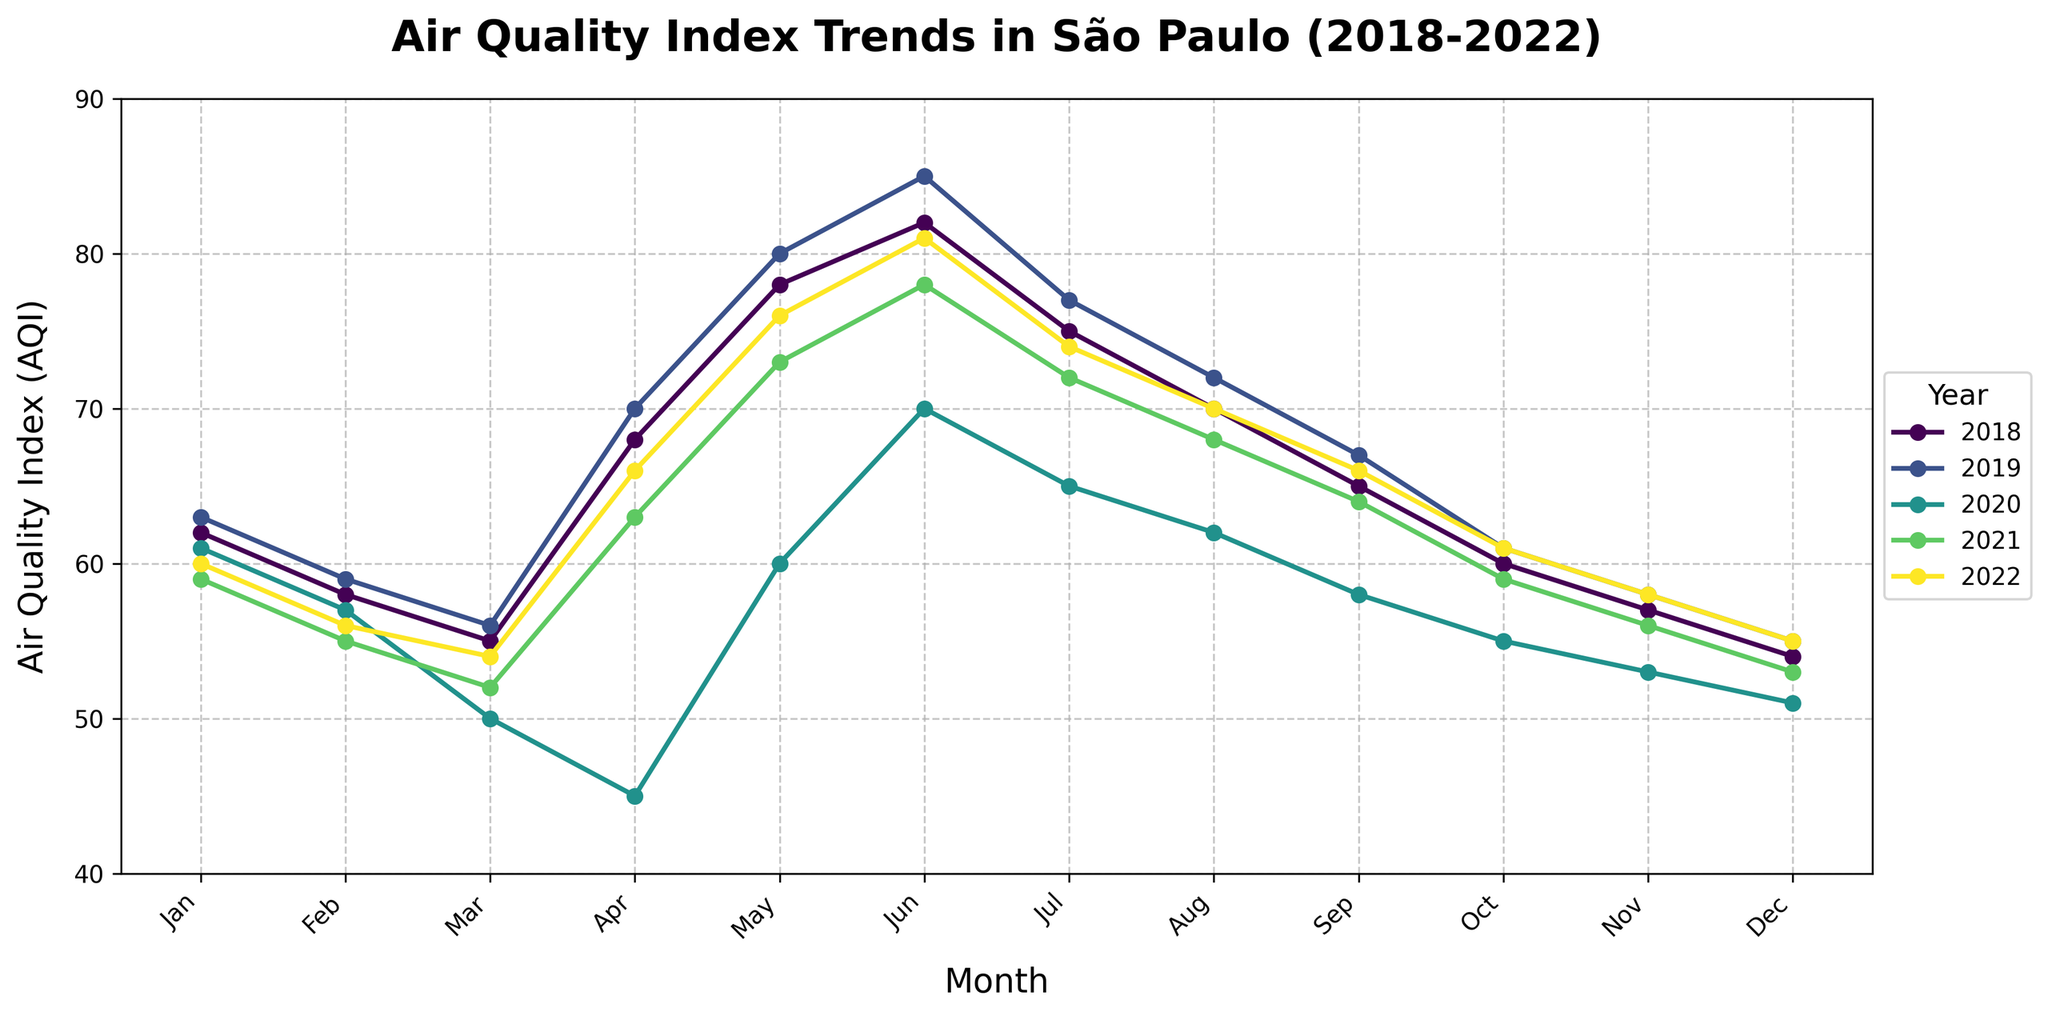What is the trend of the AQI in May from 2018 to 2022? To analyze the trend in May, observe the AQI values for May across the years: 78 (2018), 80 (2019), 60 (2020), 73 (2021), and 76 (2022). The trend shows a rise from 2018 to 2019, a significant drop in 2020, followed by a gradual increase in 2021 and 2022.
Answer: Rise, Drop, Rise Which year had the lowest AQI in April? Look at the April AQI values for each year: 68 (2018), 70 (2019), 45 (2020), 63 (2021), and 66 (2022). The year with the lowest AQI value is 2020, with an AQI of 45.
Answer: 2020 During which months in 2020 was the AQI below 60? Identify months in 2020 with AQI below 60: March (50), April (45), September (58), October (55), November (53), December (51). These months are March, April, September, October, November, and December.
Answer: March, April, September, October, November, December What is the overall lowest AQI value observed in the chart? To find the overall lowest AQI, check the minimum value across all data points: The lowest AQI value is 45 in April 2020.
Answer: 45 Compare the AQI for December in 2018 and 2022. Which year had a better AQI? Look at the AQI values for December: 54 (2018) and 55 (2022). Since a lower AQI indicates better air quality, 2018 had better AQI with a value of 54.
Answer: 2018 What is the difference in AQI between June 2019 and June 2020? Subtract the AQI of June 2020 (70) from June 2019 (85), which equals 15.
Answer: 15 In which year did July have the highest AQI and what was it? Check the AQI values for July: 75 (2018), 77 (2019), 65 (2020), 72 (2021), and 74 (2022). The highest AQI for July occurred in 2019 with a value of 77.
Answer: 2019 and 77 